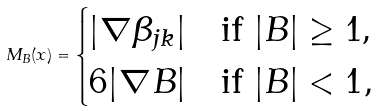<formula> <loc_0><loc_0><loc_500><loc_500>M _ { B } ( x ) = \begin{cases} | \nabla \beta _ { j k } | & \text {if $|B|\geq 1$,} \\ 6 | \nabla B | & \text {if $|B|<1$} , \end{cases}</formula> 